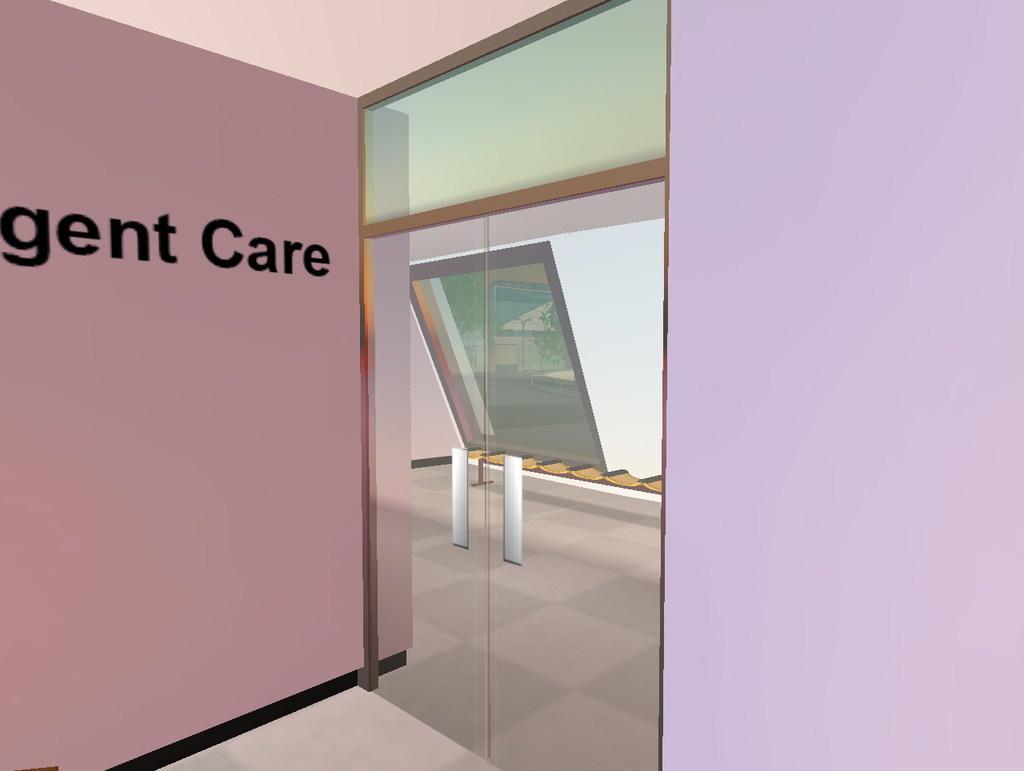Please provide a concise description of this image. In this image there is a glass door, window, board, checks floor and walls. Something is written on the board. Through the glass window I can see a light pole, trees, building and road.   